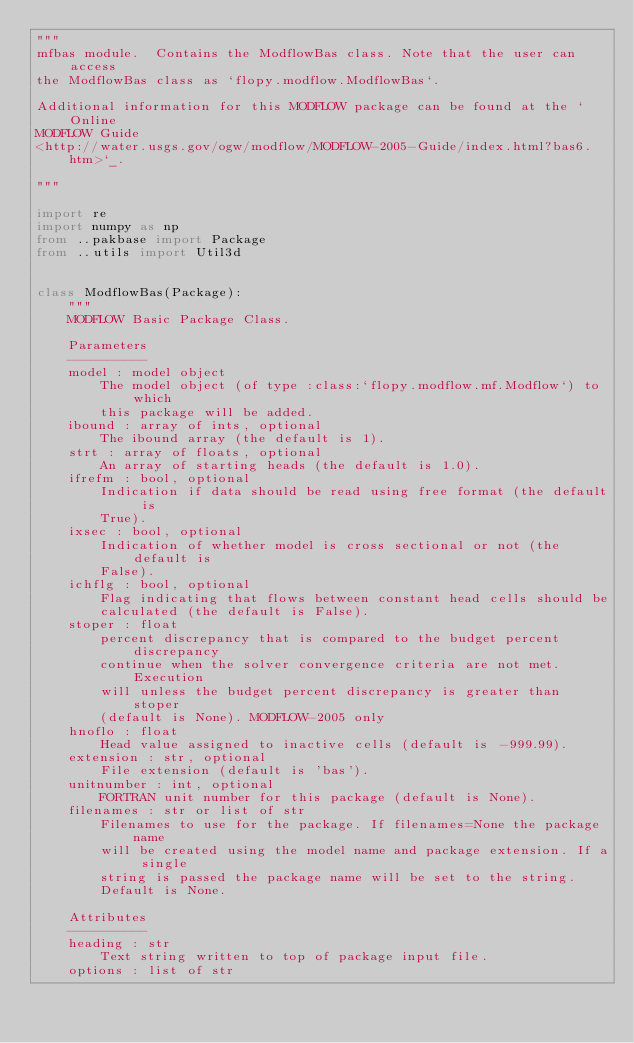<code> <loc_0><loc_0><loc_500><loc_500><_Python_>"""
mfbas module.  Contains the ModflowBas class. Note that the user can access
the ModflowBas class as `flopy.modflow.ModflowBas`.

Additional information for this MODFLOW package can be found at the `Online
MODFLOW Guide
<http://water.usgs.gov/ogw/modflow/MODFLOW-2005-Guide/index.html?bas6.htm>`_.

"""

import re
import numpy as np
from ..pakbase import Package
from ..utils import Util3d


class ModflowBas(Package):
    """
    MODFLOW Basic Package Class.

    Parameters
    ----------
    model : model object
        The model object (of type :class:`flopy.modflow.mf.Modflow`) to which
        this package will be added.
    ibound : array of ints, optional
        The ibound array (the default is 1).
    strt : array of floats, optional
        An array of starting heads (the default is 1.0).
    ifrefm : bool, optional
        Indication if data should be read using free format (the default is
        True).
    ixsec : bool, optional
        Indication of whether model is cross sectional or not (the default is
        False).
    ichflg : bool, optional
        Flag indicating that flows between constant head cells should be
        calculated (the default is False).
    stoper : float
        percent discrepancy that is compared to the budget percent discrepancy
        continue when the solver convergence criteria are not met.  Execution
        will unless the budget percent discrepancy is greater than stoper
        (default is None). MODFLOW-2005 only
    hnoflo : float
        Head value assigned to inactive cells (default is -999.99).
    extension : str, optional
        File extension (default is 'bas').
    unitnumber : int, optional
        FORTRAN unit number for this package (default is None).
    filenames : str or list of str
        Filenames to use for the package. If filenames=None the package name
        will be created using the model name and package extension. If a single
        string is passed the package name will be set to the string.
        Default is None.

    Attributes
    ----------
    heading : str
        Text string written to top of package input file.
    options : list of str</code> 